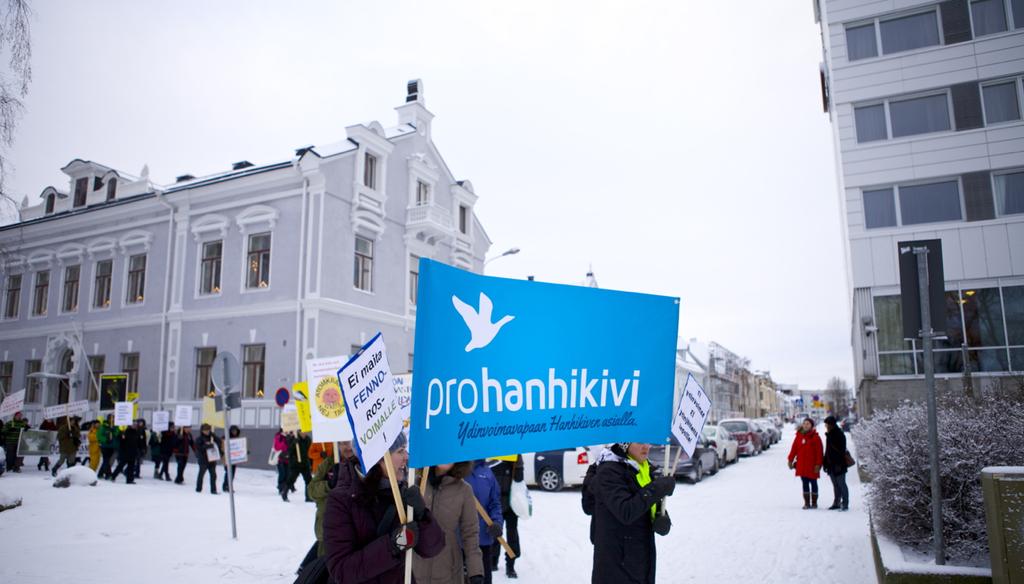What does the blue sign say?
Your answer should be compact. Prohanhikivi. What is the last letter on the blue sign?
Your response must be concise. I. 